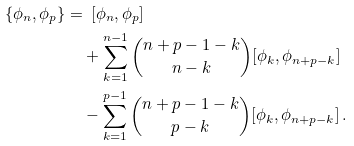<formula> <loc_0><loc_0><loc_500><loc_500>\{ \phi _ { n } , \phi _ { p } \} = & \ \ [ \phi _ { n } , \phi _ { p } ] \\ & + \sum _ { k = 1 } ^ { n - 1 } \binom { n + p - 1 - k } { n - k } [ \phi _ { k } , \phi _ { n + p - k } ] \\ & - \sum _ { k = 1 } ^ { p - 1 } \binom { n + p - 1 - k } { p - k } [ \phi _ { k } , \phi _ { n + p - k } ] \, . \\</formula> 